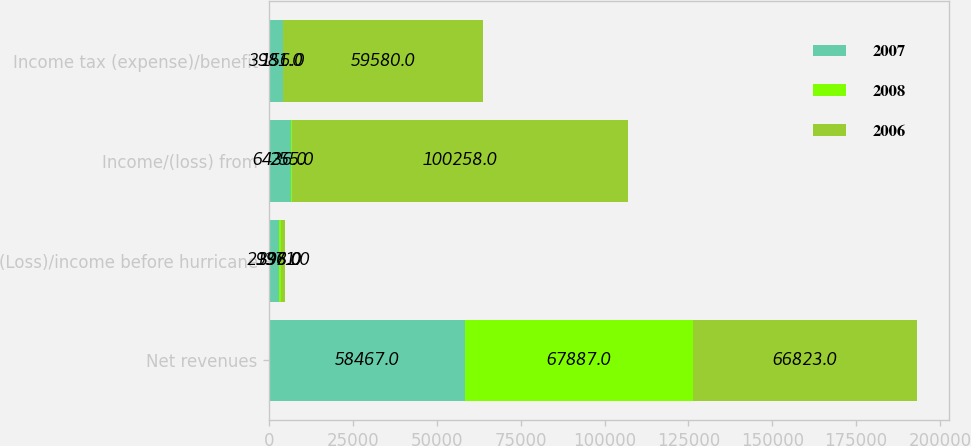<chart> <loc_0><loc_0><loc_500><loc_500><stacked_bar_chart><ecel><fcel>Net revenues<fcel>(Loss)/income before hurricane<fcel>Income/(loss) from<fcel>Income tax (expense)/benefit<nl><fcel>2007<fcel>58467<fcel>2996<fcel>6436<fcel>3981<nl><fcel>2008<fcel>67887<fcel>398<fcel>255<fcel>156<nl><fcel>2006<fcel>66823<fcel>1371<fcel>100258<fcel>59580<nl></chart> 